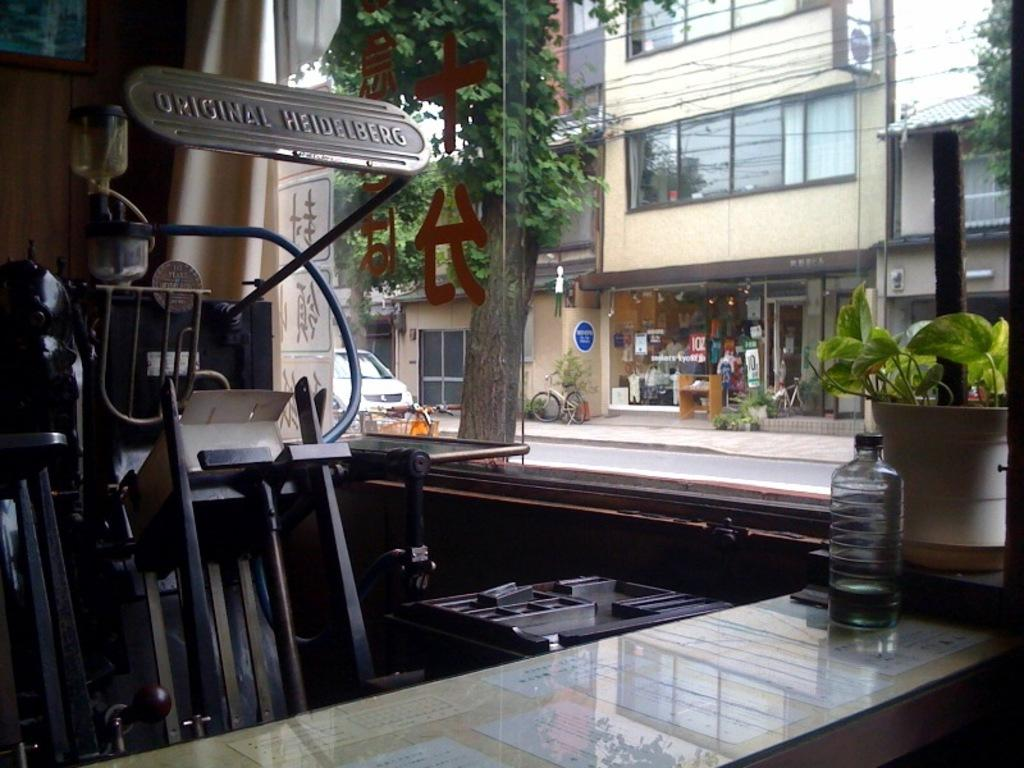<image>
Share a concise interpretation of the image provided. A counter near a piece of equipment that reads Original Heidelberg. 